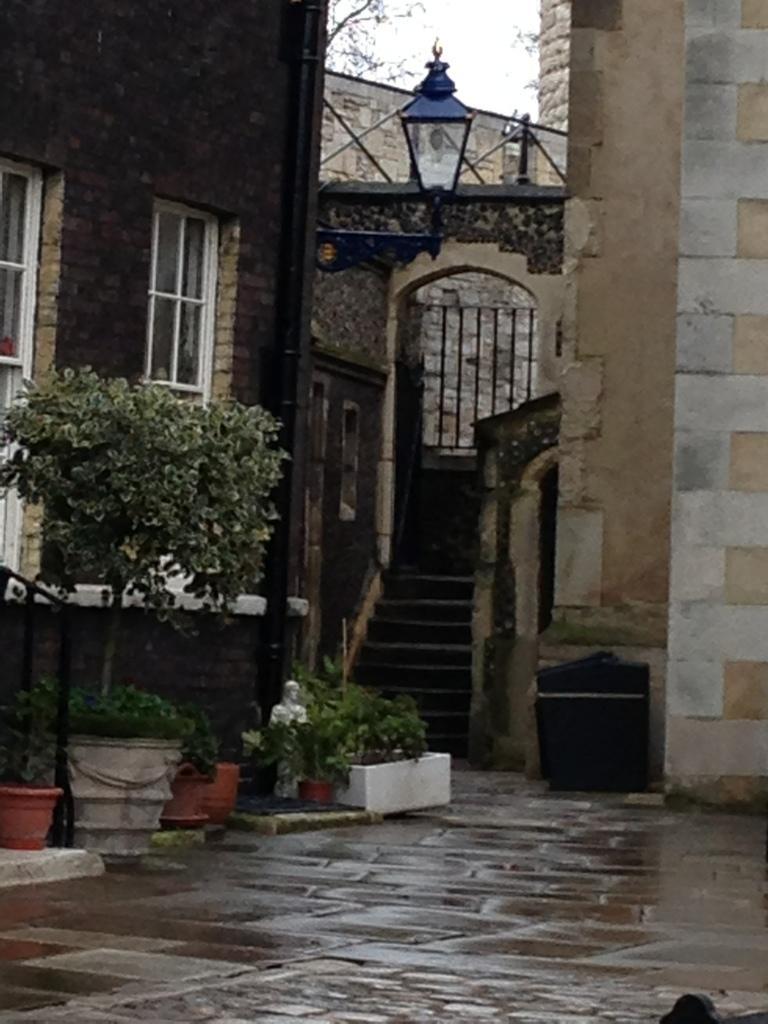In one or two sentences, can you explain what this image depicts? In this picture we can see few buildings, plants and trees, and also we can find few metal rods. 